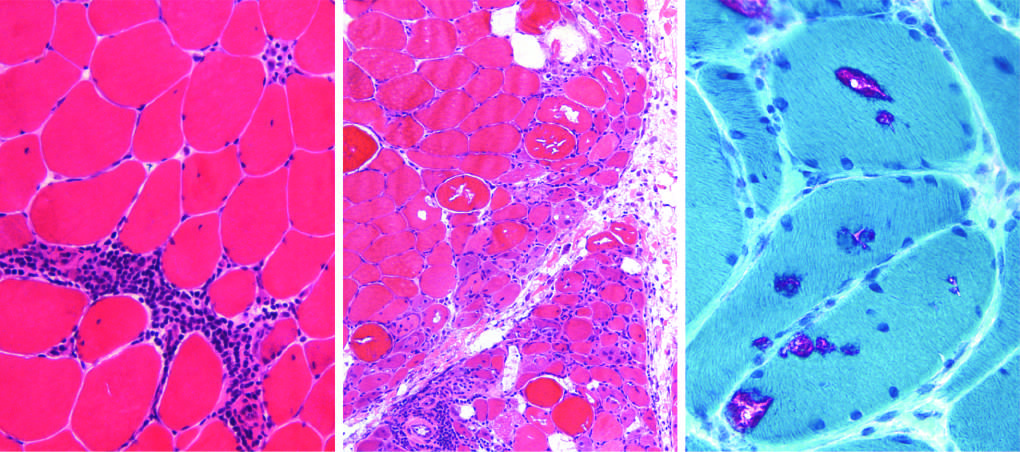s polymyositis characterized by endomysial inflammatory infiltrates and myofiber necrosis (arrow)?
Answer the question using a single word or phrase. Yes 